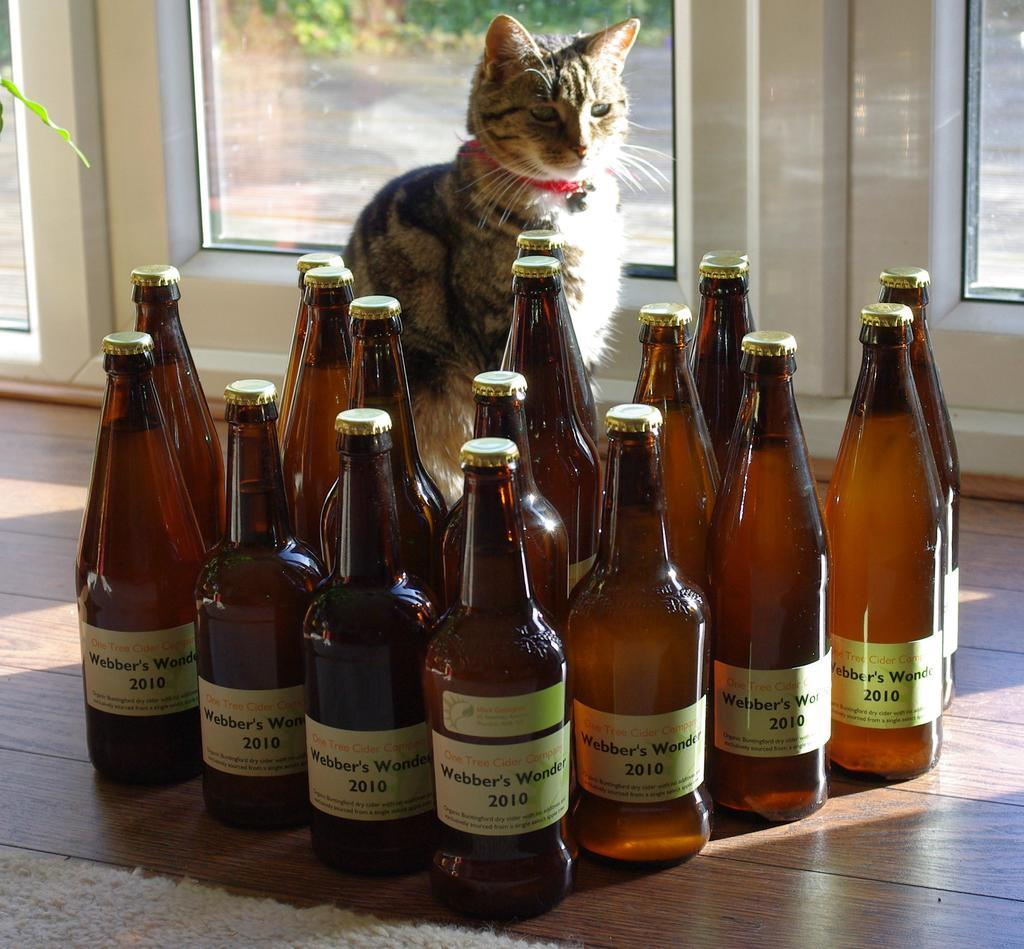What is in the bottles that are visible in the image? The bottles are filled with drink. Where are the bottles located in the image? The bottles are on the floor. What animal is present in the image? There is a cat in the image. How is the cat positioned in relation to the bottles? The cat is in front of the bottles. What architectural feature can be seen in the image? There is a door visible in the image. Where is the door located in relation to the cat? The door is at the back side of the cat. What type of butter can be seen on the cat's paws in the image? There is no butter present on the cat's paws or anywhere else in the image. Is the cat attending school in the image? There is no indication of a school or any educational activity in the image. 